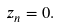<formula> <loc_0><loc_0><loc_500><loc_500>z _ { n } = 0 .</formula> 